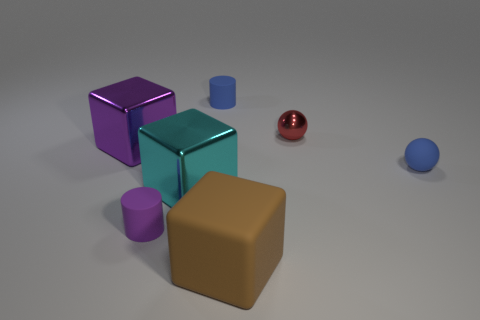Is the number of large purple shiny things that are to the right of the cyan block the same as the number of small blue matte cylinders that are in front of the purple matte object?
Provide a short and direct response. Yes. What is the color of the ball that is the same material as the big brown thing?
Offer a very short reply. Blue. There is a metal sphere; is its color the same as the small rubber thing that is right of the large rubber object?
Offer a terse response. No. There is a cylinder that is in front of the cylinder that is to the right of the cyan cube; are there any small metallic balls that are on the left side of it?
Your answer should be compact. No. What is the shape of the small purple object that is the same material as the brown thing?
Provide a short and direct response. Cylinder. Is there anything else that has the same shape as the purple matte thing?
Offer a very short reply. Yes. There is a big purple object; what shape is it?
Your answer should be compact. Cube. Is the shape of the purple thing in front of the purple block the same as  the tiny red metal object?
Your response must be concise. No. Is the number of metallic objects on the left side of the small purple rubber cylinder greater than the number of tiny spheres that are behind the blue rubber cylinder?
Provide a short and direct response. Yes. How many other things are the same size as the blue rubber ball?
Your response must be concise. 3. 